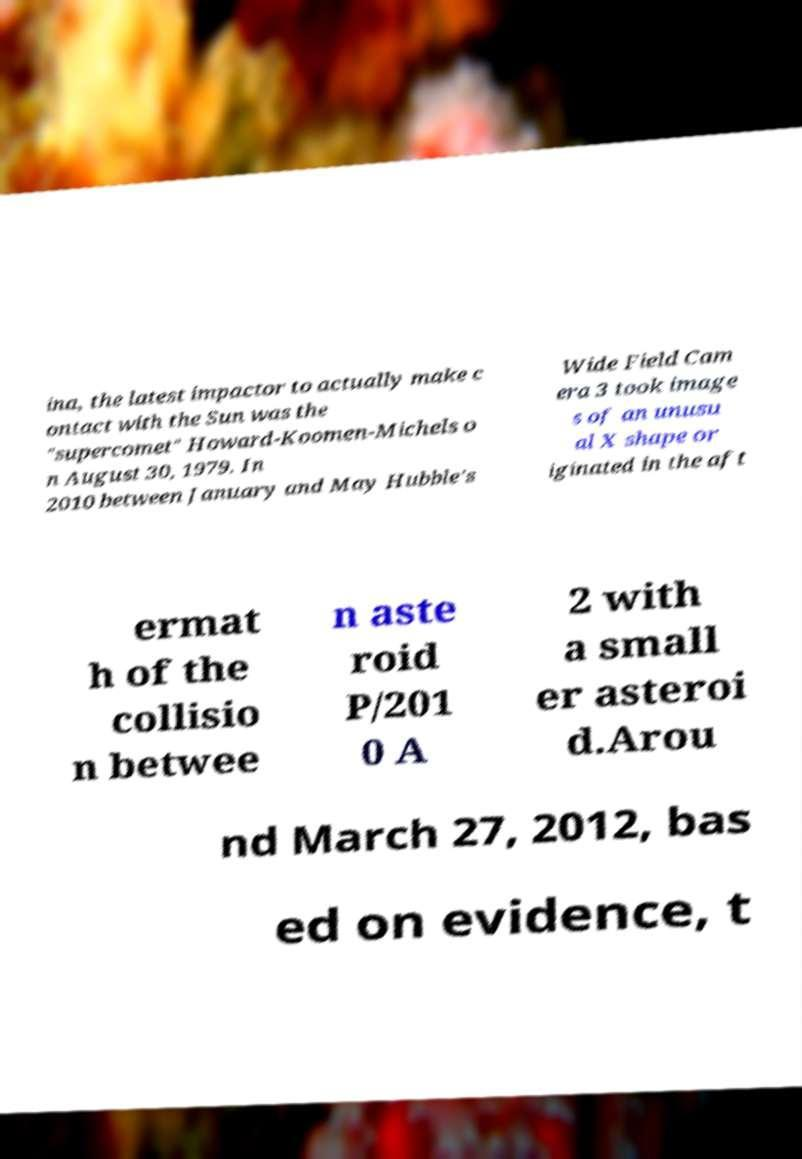What messages or text are displayed in this image? I need them in a readable, typed format. ina, the latest impactor to actually make c ontact with the Sun was the "supercomet" Howard-Koomen-Michels o n August 30, 1979. In 2010 between January and May Hubble's Wide Field Cam era 3 took image s of an unusu al X shape or iginated in the aft ermat h of the collisio n betwee n aste roid P/201 0 A 2 with a small er asteroi d.Arou nd March 27, 2012, bas ed on evidence, t 